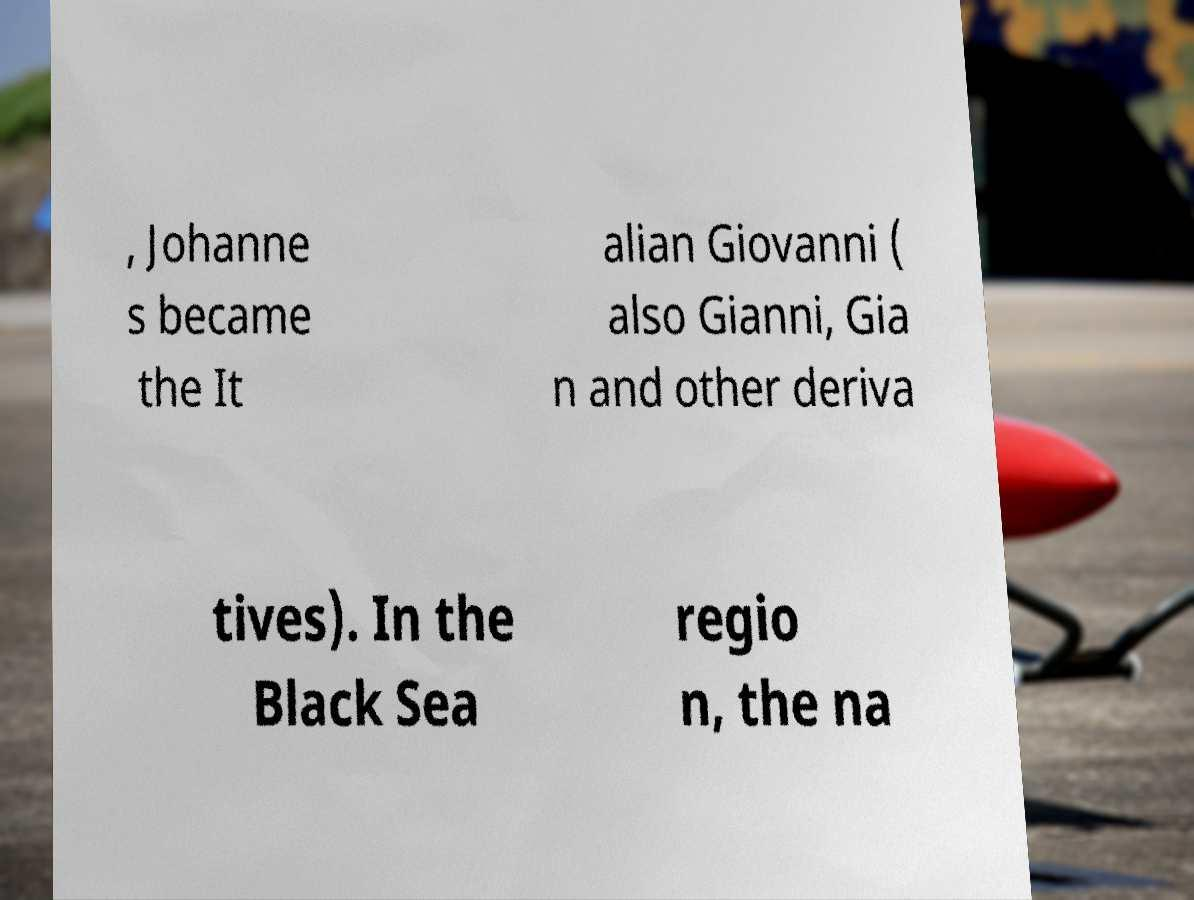Can you accurately transcribe the text from the provided image for me? , Johanne s became the It alian Giovanni ( also Gianni, Gia n and other deriva tives). In the Black Sea regio n, the na 